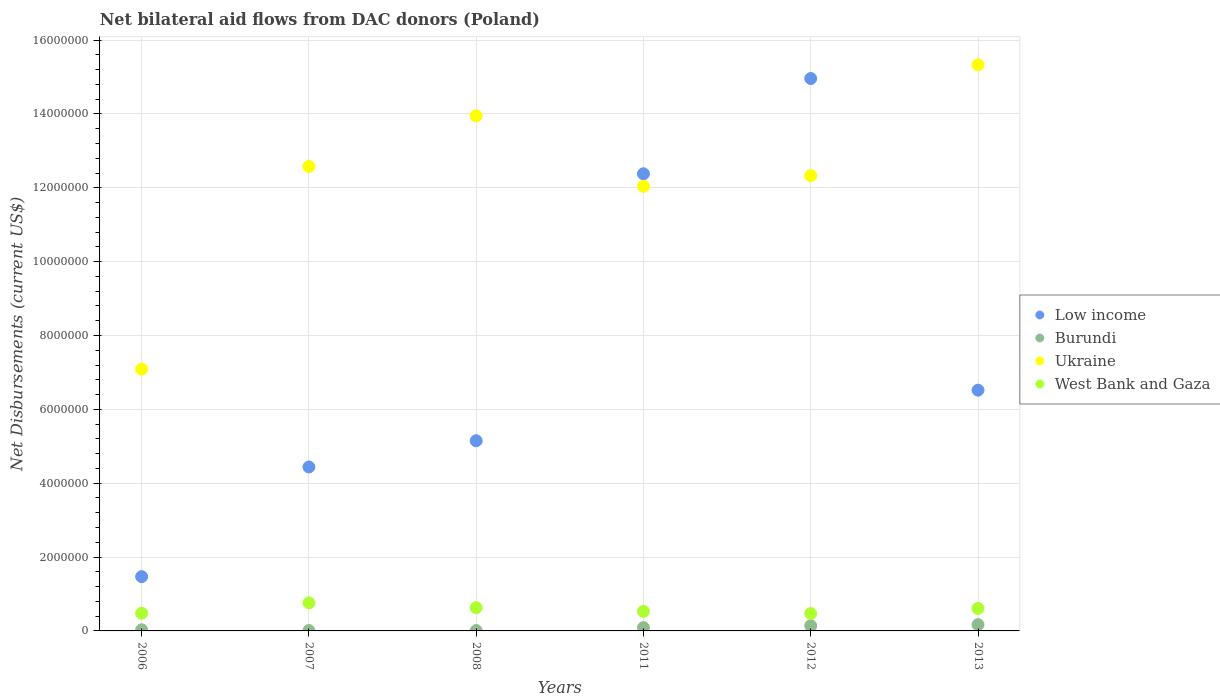How many different coloured dotlines are there?
Offer a terse response. 4. What is the net bilateral aid flows in Ukraine in 2008?
Provide a short and direct response. 1.40e+07. Across all years, what is the minimum net bilateral aid flows in Low income?
Keep it short and to the point. 1.47e+06. What is the total net bilateral aid flows in West Bank and Gaza in the graph?
Your response must be concise. 3.48e+06. What is the difference between the net bilateral aid flows in Burundi in 2006 and that in 2012?
Provide a succinct answer. -1.10e+05. What is the difference between the net bilateral aid flows in Low income in 2008 and the net bilateral aid flows in Ukraine in 2012?
Your response must be concise. -7.18e+06. What is the average net bilateral aid flows in Burundi per year?
Keep it short and to the point. 7.50e+04. In the year 2013, what is the difference between the net bilateral aid flows in Low income and net bilateral aid flows in Ukraine?
Give a very brief answer. -8.81e+06. In how many years, is the net bilateral aid flows in West Bank and Gaza greater than 12000000 US$?
Offer a terse response. 0. What is the ratio of the net bilateral aid flows in Ukraine in 2007 to that in 2011?
Ensure brevity in your answer.  1.04. Is the net bilateral aid flows in Ukraine in 2008 less than that in 2011?
Your response must be concise. No. Is the difference between the net bilateral aid flows in Low income in 2006 and 2007 greater than the difference between the net bilateral aid flows in Ukraine in 2006 and 2007?
Offer a very short reply. Yes. What is the difference between the highest and the second highest net bilateral aid flows in Burundi?
Keep it short and to the point. 3.00e+04. What is the difference between the highest and the lowest net bilateral aid flows in Ukraine?
Provide a short and direct response. 8.24e+06. In how many years, is the net bilateral aid flows in Ukraine greater than the average net bilateral aid flows in Ukraine taken over all years?
Offer a very short reply. 4. Is it the case that in every year, the sum of the net bilateral aid flows in West Bank and Gaza and net bilateral aid flows in Ukraine  is greater than the sum of net bilateral aid flows in Burundi and net bilateral aid flows in Low income?
Offer a very short reply. No. Is the net bilateral aid flows in Ukraine strictly greater than the net bilateral aid flows in Burundi over the years?
Your answer should be very brief. Yes. Is the net bilateral aid flows in Low income strictly less than the net bilateral aid flows in Ukraine over the years?
Your answer should be very brief. No. Does the graph contain any zero values?
Your response must be concise. No. Where does the legend appear in the graph?
Offer a terse response. Center right. How are the legend labels stacked?
Give a very brief answer. Vertical. What is the title of the graph?
Keep it short and to the point. Net bilateral aid flows from DAC donors (Poland). What is the label or title of the X-axis?
Keep it short and to the point. Years. What is the label or title of the Y-axis?
Your answer should be compact. Net Disbursements (current US$). What is the Net Disbursements (current US$) in Low income in 2006?
Make the answer very short. 1.47e+06. What is the Net Disbursements (current US$) of Burundi in 2006?
Make the answer very short. 3.00e+04. What is the Net Disbursements (current US$) of Ukraine in 2006?
Provide a short and direct response. 7.09e+06. What is the Net Disbursements (current US$) of West Bank and Gaza in 2006?
Your answer should be compact. 4.80e+05. What is the Net Disbursements (current US$) of Low income in 2007?
Offer a terse response. 4.44e+06. What is the Net Disbursements (current US$) in Burundi in 2007?
Ensure brevity in your answer.  10000. What is the Net Disbursements (current US$) of Ukraine in 2007?
Offer a very short reply. 1.26e+07. What is the Net Disbursements (current US$) in West Bank and Gaza in 2007?
Provide a succinct answer. 7.60e+05. What is the Net Disbursements (current US$) in Low income in 2008?
Offer a very short reply. 5.15e+06. What is the Net Disbursements (current US$) in Burundi in 2008?
Provide a short and direct response. 10000. What is the Net Disbursements (current US$) of Ukraine in 2008?
Make the answer very short. 1.40e+07. What is the Net Disbursements (current US$) of West Bank and Gaza in 2008?
Ensure brevity in your answer.  6.30e+05. What is the Net Disbursements (current US$) of Low income in 2011?
Your response must be concise. 1.24e+07. What is the Net Disbursements (current US$) of Burundi in 2011?
Give a very brief answer. 9.00e+04. What is the Net Disbursements (current US$) in Ukraine in 2011?
Your answer should be compact. 1.20e+07. What is the Net Disbursements (current US$) in West Bank and Gaza in 2011?
Make the answer very short. 5.30e+05. What is the Net Disbursements (current US$) in Low income in 2012?
Your response must be concise. 1.50e+07. What is the Net Disbursements (current US$) of Ukraine in 2012?
Ensure brevity in your answer.  1.23e+07. What is the Net Disbursements (current US$) of Low income in 2013?
Offer a very short reply. 6.52e+06. What is the Net Disbursements (current US$) of Ukraine in 2013?
Your answer should be compact. 1.53e+07. What is the Net Disbursements (current US$) in West Bank and Gaza in 2013?
Your answer should be compact. 6.10e+05. Across all years, what is the maximum Net Disbursements (current US$) in Low income?
Ensure brevity in your answer.  1.50e+07. Across all years, what is the maximum Net Disbursements (current US$) of Burundi?
Ensure brevity in your answer.  1.70e+05. Across all years, what is the maximum Net Disbursements (current US$) of Ukraine?
Keep it short and to the point. 1.53e+07. Across all years, what is the maximum Net Disbursements (current US$) of West Bank and Gaza?
Your answer should be very brief. 7.60e+05. Across all years, what is the minimum Net Disbursements (current US$) in Low income?
Your response must be concise. 1.47e+06. Across all years, what is the minimum Net Disbursements (current US$) of Burundi?
Offer a very short reply. 10000. Across all years, what is the minimum Net Disbursements (current US$) of Ukraine?
Offer a terse response. 7.09e+06. What is the total Net Disbursements (current US$) in Low income in the graph?
Your answer should be compact. 4.49e+07. What is the total Net Disbursements (current US$) in Ukraine in the graph?
Give a very brief answer. 7.33e+07. What is the total Net Disbursements (current US$) of West Bank and Gaza in the graph?
Make the answer very short. 3.48e+06. What is the difference between the Net Disbursements (current US$) in Low income in 2006 and that in 2007?
Give a very brief answer. -2.97e+06. What is the difference between the Net Disbursements (current US$) of Burundi in 2006 and that in 2007?
Keep it short and to the point. 2.00e+04. What is the difference between the Net Disbursements (current US$) in Ukraine in 2006 and that in 2007?
Offer a very short reply. -5.49e+06. What is the difference between the Net Disbursements (current US$) of West Bank and Gaza in 2006 and that in 2007?
Offer a terse response. -2.80e+05. What is the difference between the Net Disbursements (current US$) of Low income in 2006 and that in 2008?
Your response must be concise. -3.68e+06. What is the difference between the Net Disbursements (current US$) in Burundi in 2006 and that in 2008?
Provide a short and direct response. 2.00e+04. What is the difference between the Net Disbursements (current US$) in Ukraine in 2006 and that in 2008?
Your answer should be very brief. -6.86e+06. What is the difference between the Net Disbursements (current US$) in Low income in 2006 and that in 2011?
Give a very brief answer. -1.09e+07. What is the difference between the Net Disbursements (current US$) of Ukraine in 2006 and that in 2011?
Make the answer very short. -4.95e+06. What is the difference between the Net Disbursements (current US$) in Low income in 2006 and that in 2012?
Give a very brief answer. -1.35e+07. What is the difference between the Net Disbursements (current US$) of Ukraine in 2006 and that in 2012?
Keep it short and to the point. -5.24e+06. What is the difference between the Net Disbursements (current US$) in Low income in 2006 and that in 2013?
Your response must be concise. -5.05e+06. What is the difference between the Net Disbursements (current US$) in Burundi in 2006 and that in 2013?
Keep it short and to the point. -1.40e+05. What is the difference between the Net Disbursements (current US$) in Ukraine in 2006 and that in 2013?
Your answer should be very brief. -8.24e+06. What is the difference between the Net Disbursements (current US$) in West Bank and Gaza in 2006 and that in 2013?
Your response must be concise. -1.30e+05. What is the difference between the Net Disbursements (current US$) of Low income in 2007 and that in 2008?
Ensure brevity in your answer.  -7.10e+05. What is the difference between the Net Disbursements (current US$) in Ukraine in 2007 and that in 2008?
Your answer should be very brief. -1.37e+06. What is the difference between the Net Disbursements (current US$) in West Bank and Gaza in 2007 and that in 2008?
Keep it short and to the point. 1.30e+05. What is the difference between the Net Disbursements (current US$) in Low income in 2007 and that in 2011?
Offer a terse response. -7.94e+06. What is the difference between the Net Disbursements (current US$) in Ukraine in 2007 and that in 2011?
Give a very brief answer. 5.40e+05. What is the difference between the Net Disbursements (current US$) in West Bank and Gaza in 2007 and that in 2011?
Offer a very short reply. 2.30e+05. What is the difference between the Net Disbursements (current US$) of Low income in 2007 and that in 2012?
Your answer should be very brief. -1.05e+07. What is the difference between the Net Disbursements (current US$) of Ukraine in 2007 and that in 2012?
Give a very brief answer. 2.50e+05. What is the difference between the Net Disbursements (current US$) in West Bank and Gaza in 2007 and that in 2012?
Your answer should be very brief. 2.90e+05. What is the difference between the Net Disbursements (current US$) in Low income in 2007 and that in 2013?
Your response must be concise. -2.08e+06. What is the difference between the Net Disbursements (current US$) in Burundi in 2007 and that in 2013?
Keep it short and to the point. -1.60e+05. What is the difference between the Net Disbursements (current US$) of Ukraine in 2007 and that in 2013?
Your answer should be compact. -2.75e+06. What is the difference between the Net Disbursements (current US$) in Low income in 2008 and that in 2011?
Make the answer very short. -7.23e+06. What is the difference between the Net Disbursements (current US$) of Burundi in 2008 and that in 2011?
Make the answer very short. -8.00e+04. What is the difference between the Net Disbursements (current US$) in Ukraine in 2008 and that in 2011?
Make the answer very short. 1.91e+06. What is the difference between the Net Disbursements (current US$) in West Bank and Gaza in 2008 and that in 2011?
Make the answer very short. 1.00e+05. What is the difference between the Net Disbursements (current US$) in Low income in 2008 and that in 2012?
Ensure brevity in your answer.  -9.81e+06. What is the difference between the Net Disbursements (current US$) of Ukraine in 2008 and that in 2012?
Keep it short and to the point. 1.62e+06. What is the difference between the Net Disbursements (current US$) in West Bank and Gaza in 2008 and that in 2012?
Make the answer very short. 1.60e+05. What is the difference between the Net Disbursements (current US$) in Low income in 2008 and that in 2013?
Offer a terse response. -1.37e+06. What is the difference between the Net Disbursements (current US$) of Burundi in 2008 and that in 2013?
Keep it short and to the point. -1.60e+05. What is the difference between the Net Disbursements (current US$) in Ukraine in 2008 and that in 2013?
Ensure brevity in your answer.  -1.38e+06. What is the difference between the Net Disbursements (current US$) in West Bank and Gaza in 2008 and that in 2013?
Your answer should be very brief. 2.00e+04. What is the difference between the Net Disbursements (current US$) in Low income in 2011 and that in 2012?
Ensure brevity in your answer.  -2.58e+06. What is the difference between the Net Disbursements (current US$) in Burundi in 2011 and that in 2012?
Offer a very short reply. -5.00e+04. What is the difference between the Net Disbursements (current US$) in Ukraine in 2011 and that in 2012?
Provide a short and direct response. -2.90e+05. What is the difference between the Net Disbursements (current US$) of Low income in 2011 and that in 2013?
Offer a terse response. 5.86e+06. What is the difference between the Net Disbursements (current US$) in Burundi in 2011 and that in 2013?
Your answer should be very brief. -8.00e+04. What is the difference between the Net Disbursements (current US$) in Ukraine in 2011 and that in 2013?
Your response must be concise. -3.29e+06. What is the difference between the Net Disbursements (current US$) of Low income in 2012 and that in 2013?
Provide a short and direct response. 8.44e+06. What is the difference between the Net Disbursements (current US$) in Burundi in 2012 and that in 2013?
Give a very brief answer. -3.00e+04. What is the difference between the Net Disbursements (current US$) of West Bank and Gaza in 2012 and that in 2013?
Give a very brief answer. -1.40e+05. What is the difference between the Net Disbursements (current US$) in Low income in 2006 and the Net Disbursements (current US$) in Burundi in 2007?
Make the answer very short. 1.46e+06. What is the difference between the Net Disbursements (current US$) of Low income in 2006 and the Net Disbursements (current US$) of Ukraine in 2007?
Your response must be concise. -1.11e+07. What is the difference between the Net Disbursements (current US$) of Low income in 2006 and the Net Disbursements (current US$) of West Bank and Gaza in 2007?
Your answer should be compact. 7.10e+05. What is the difference between the Net Disbursements (current US$) in Burundi in 2006 and the Net Disbursements (current US$) in Ukraine in 2007?
Provide a succinct answer. -1.26e+07. What is the difference between the Net Disbursements (current US$) in Burundi in 2006 and the Net Disbursements (current US$) in West Bank and Gaza in 2007?
Your response must be concise. -7.30e+05. What is the difference between the Net Disbursements (current US$) of Ukraine in 2006 and the Net Disbursements (current US$) of West Bank and Gaza in 2007?
Provide a short and direct response. 6.33e+06. What is the difference between the Net Disbursements (current US$) of Low income in 2006 and the Net Disbursements (current US$) of Burundi in 2008?
Offer a terse response. 1.46e+06. What is the difference between the Net Disbursements (current US$) in Low income in 2006 and the Net Disbursements (current US$) in Ukraine in 2008?
Provide a succinct answer. -1.25e+07. What is the difference between the Net Disbursements (current US$) in Low income in 2006 and the Net Disbursements (current US$) in West Bank and Gaza in 2008?
Your answer should be compact. 8.40e+05. What is the difference between the Net Disbursements (current US$) of Burundi in 2006 and the Net Disbursements (current US$) of Ukraine in 2008?
Offer a terse response. -1.39e+07. What is the difference between the Net Disbursements (current US$) of Burundi in 2006 and the Net Disbursements (current US$) of West Bank and Gaza in 2008?
Keep it short and to the point. -6.00e+05. What is the difference between the Net Disbursements (current US$) of Ukraine in 2006 and the Net Disbursements (current US$) of West Bank and Gaza in 2008?
Ensure brevity in your answer.  6.46e+06. What is the difference between the Net Disbursements (current US$) in Low income in 2006 and the Net Disbursements (current US$) in Burundi in 2011?
Provide a succinct answer. 1.38e+06. What is the difference between the Net Disbursements (current US$) of Low income in 2006 and the Net Disbursements (current US$) of Ukraine in 2011?
Make the answer very short. -1.06e+07. What is the difference between the Net Disbursements (current US$) in Low income in 2006 and the Net Disbursements (current US$) in West Bank and Gaza in 2011?
Ensure brevity in your answer.  9.40e+05. What is the difference between the Net Disbursements (current US$) in Burundi in 2006 and the Net Disbursements (current US$) in Ukraine in 2011?
Your answer should be compact. -1.20e+07. What is the difference between the Net Disbursements (current US$) of Burundi in 2006 and the Net Disbursements (current US$) of West Bank and Gaza in 2011?
Your answer should be compact. -5.00e+05. What is the difference between the Net Disbursements (current US$) in Ukraine in 2006 and the Net Disbursements (current US$) in West Bank and Gaza in 2011?
Your answer should be compact. 6.56e+06. What is the difference between the Net Disbursements (current US$) in Low income in 2006 and the Net Disbursements (current US$) in Burundi in 2012?
Ensure brevity in your answer.  1.33e+06. What is the difference between the Net Disbursements (current US$) in Low income in 2006 and the Net Disbursements (current US$) in Ukraine in 2012?
Your answer should be compact. -1.09e+07. What is the difference between the Net Disbursements (current US$) of Low income in 2006 and the Net Disbursements (current US$) of West Bank and Gaza in 2012?
Offer a terse response. 1.00e+06. What is the difference between the Net Disbursements (current US$) in Burundi in 2006 and the Net Disbursements (current US$) in Ukraine in 2012?
Ensure brevity in your answer.  -1.23e+07. What is the difference between the Net Disbursements (current US$) of Burundi in 2006 and the Net Disbursements (current US$) of West Bank and Gaza in 2012?
Your answer should be very brief. -4.40e+05. What is the difference between the Net Disbursements (current US$) in Ukraine in 2006 and the Net Disbursements (current US$) in West Bank and Gaza in 2012?
Your answer should be very brief. 6.62e+06. What is the difference between the Net Disbursements (current US$) of Low income in 2006 and the Net Disbursements (current US$) of Burundi in 2013?
Give a very brief answer. 1.30e+06. What is the difference between the Net Disbursements (current US$) of Low income in 2006 and the Net Disbursements (current US$) of Ukraine in 2013?
Give a very brief answer. -1.39e+07. What is the difference between the Net Disbursements (current US$) in Low income in 2006 and the Net Disbursements (current US$) in West Bank and Gaza in 2013?
Your response must be concise. 8.60e+05. What is the difference between the Net Disbursements (current US$) in Burundi in 2006 and the Net Disbursements (current US$) in Ukraine in 2013?
Offer a very short reply. -1.53e+07. What is the difference between the Net Disbursements (current US$) in Burundi in 2006 and the Net Disbursements (current US$) in West Bank and Gaza in 2013?
Offer a terse response. -5.80e+05. What is the difference between the Net Disbursements (current US$) of Ukraine in 2006 and the Net Disbursements (current US$) of West Bank and Gaza in 2013?
Make the answer very short. 6.48e+06. What is the difference between the Net Disbursements (current US$) of Low income in 2007 and the Net Disbursements (current US$) of Burundi in 2008?
Offer a very short reply. 4.43e+06. What is the difference between the Net Disbursements (current US$) in Low income in 2007 and the Net Disbursements (current US$) in Ukraine in 2008?
Offer a terse response. -9.51e+06. What is the difference between the Net Disbursements (current US$) of Low income in 2007 and the Net Disbursements (current US$) of West Bank and Gaza in 2008?
Offer a very short reply. 3.81e+06. What is the difference between the Net Disbursements (current US$) in Burundi in 2007 and the Net Disbursements (current US$) in Ukraine in 2008?
Provide a short and direct response. -1.39e+07. What is the difference between the Net Disbursements (current US$) of Burundi in 2007 and the Net Disbursements (current US$) of West Bank and Gaza in 2008?
Your answer should be very brief. -6.20e+05. What is the difference between the Net Disbursements (current US$) in Ukraine in 2007 and the Net Disbursements (current US$) in West Bank and Gaza in 2008?
Your response must be concise. 1.20e+07. What is the difference between the Net Disbursements (current US$) of Low income in 2007 and the Net Disbursements (current US$) of Burundi in 2011?
Offer a very short reply. 4.35e+06. What is the difference between the Net Disbursements (current US$) of Low income in 2007 and the Net Disbursements (current US$) of Ukraine in 2011?
Provide a short and direct response. -7.60e+06. What is the difference between the Net Disbursements (current US$) in Low income in 2007 and the Net Disbursements (current US$) in West Bank and Gaza in 2011?
Your response must be concise. 3.91e+06. What is the difference between the Net Disbursements (current US$) of Burundi in 2007 and the Net Disbursements (current US$) of Ukraine in 2011?
Your response must be concise. -1.20e+07. What is the difference between the Net Disbursements (current US$) in Burundi in 2007 and the Net Disbursements (current US$) in West Bank and Gaza in 2011?
Your answer should be compact. -5.20e+05. What is the difference between the Net Disbursements (current US$) of Ukraine in 2007 and the Net Disbursements (current US$) of West Bank and Gaza in 2011?
Your response must be concise. 1.20e+07. What is the difference between the Net Disbursements (current US$) of Low income in 2007 and the Net Disbursements (current US$) of Burundi in 2012?
Offer a terse response. 4.30e+06. What is the difference between the Net Disbursements (current US$) of Low income in 2007 and the Net Disbursements (current US$) of Ukraine in 2012?
Make the answer very short. -7.89e+06. What is the difference between the Net Disbursements (current US$) in Low income in 2007 and the Net Disbursements (current US$) in West Bank and Gaza in 2012?
Your response must be concise. 3.97e+06. What is the difference between the Net Disbursements (current US$) in Burundi in 2007 and the Net Disbursements (current US$) in Ukraine in 2012?
Provide a succinct answer. -1.23e+07. What is the difference between the Net Disbursements (current US$) in Burundi in 2007 and the Net Disbursements (current US$) in West Bank and Gaza in 2012?
Provide a succinct answer. -4.60e+05. What is the difference between the Net Disbursements (current US$) in Ukraine in 2007 and the Net Disbursements (current US$) in West Bank and Gaza in 2012?
Provide a succinct answer. 1.21e+07. What is the difference between the Net Disbursements (current US$) of Low income in 2007 and the Net Disbursements (current US$) of Burundi in 2013?
Make the answer very short. 4.27e+06. What is the difference between the Net Disbursements (current US$) in Low income in 2007 and the Net Disbursements (current US$) in Ukraine in 2013?
Offer a very short reply. -1.09e+07. What is the difference between the Net Disbursements (current US$) in Low income in 2007 and the Net Disbursements (current US$) in West Bank and Gaza in 2013?
Keep it short and to the point. 3.83e+06. What is the difference between the Net Disbursements (current US$) in Burundi in 2007 and the Net Disbursements (current US$) in Ukraine in 2013?
Your answer should be very brief. -1.53e+07. What is the difference between the Net Disbursements (current US$) in Burundi in 2007 and the Net Disbursements (current US$) in West Bank and Gaza in 2013?
Offer a very short reply. -6.00e+05. What is the difference between the Net Disbursements (current US$) in Ukraine in 2007 and the Net Disbursements (current US$) in West Bank and Gaza in 2013?
Provide a short and direct response. 1.20e+07. What is the difference between the Net Disbursements (current US$) in Low income in 2008 and the Net Disbursements (current US$) in Burundi in 2011?
Give a very brief answer. 5.06e+06. What is the difference between the Net Disbursements (current US$) in Low income in 2008 and the Net Disbursements (current US$) in Ukraine in 2011?
Keep it short and to the point. -6.89e+06. What is the difference between the Net Disbursements (current US$) of Low income in 2008 and the Net Disbursements (current US$) of West Bank and Gaza in 2011?
Your answer should be very brief. 4.62e+06. What is the difference between the Net Disbursements (current US$) of Burundi in 2008 and the Net Disbursements (current US$) of Ukraine in 2011?
Provide a succinct answer. -1.20e+07. What is the difference between the Net Disbursements (current US$) in Burundi in 2008 and the Net Disbursements (current US$) in West Bank and Gaza in 2011?
Your answer should be compact. -5.20e+05. What is the difference between the Net Disbursements (current US$) in Ukraine in 2008 and the Net Disbursements (current US$) in West Bank and Gaza in 2011?
Keep it short and to the point. 1.34e+07. What is the difference between the Net Disbursements (current US$) of Low income in 2008 and the Net Disbursements (current US$) of Burundi in 2012?
Your answer should be very brief. 5.01e+06. What is the difference between the Net Disbursements (current US$) of Low income in 2008 and the Net Disbursements (current US$) of Ukraine in 2012?
Your answer should be compact. -7.18e+06. What is the difference between the Net Disbursements (current US$) of Low income in 2008 and the Net Disbursements (current US$) of West Bank and Gaza in 2012?
Provide a succinct answer. 4.68e+06. What is the difference between the Net Disbursements (current US$) of Burundi in 2008 and the Net Disbursements (current US$) of Ukraine in 2012?
Offer a very short reply. -1.23e+07. What is the difference between the Net Disbursements (current US$) in Burundi in 2008 and the Net Disbursements (current US$) in West Bank and Gaza in 2012?
Keep it short and to the point. -4.60e+05. What is the difference between the Net Disbursements (current US$) in Ukraine in 2008 and the Net Disbursements (current US$) in West Bank and Gaza in 2012?
Provide a succinct answer. 1.35e+07. What is the difference between the Net Disbursements (current US$) of Low income in 2008 and the Net Disbursements (current US$) of Burundi in 2013?
Your response must be concise. 4.98e+06. What is the difference between the Net Disbursements (current US$) of Low income in 2008 and the Net Disbursements (current US$) of Ukraine in 2013?
Keep it short and to the point. -1.02e+07. What is the difference between the Net Disbursements (current US$) in Low income in 2008 and the Net Disbursements (current US$) in West Bank and Gaza in 2013?
Keep it short and to the point. 4.54e+06. What is the difference between the Net Disbursements (current US$) of Burundi in 2008 and the Net Disbursements (current US$) of Ukraine in 2013?
Keep it short and to the point. -1.53e+07. What is the difference between the Net Disbursements (current US$) in Burundi in 2008 and the Net Disbursements (current US$) in West Bank and Gaza in 2013?
Your answer should be very brief. -6.00e+05. What is the difference between the Net Disbursements (current US$) of Ukraine in 2008 and the Net Disbursements (current US$) of West Bank and Gaza in 2013?
Your answer should be compact. 1.33e+07. What is the difference between the Net Disbursements (current US$) of Low income in 2011 and the Net Disbursements (current US$) of Burundi in 2012?
Offer a very short reply. 1.22e+07. What is the difference between the Net Disbursements (current US$) of Low income in 2011 and the Net Disbursements (current US$) of West Bank and Gaza in 2012?
Give a very brief answer. 1.19e+07. What is the difference between the Net Disbursements (current US$) in Burundi in 2011 and the Net Disbursements (current US$) in Ukraine in 2012?
Provide a short and direct response. -1.22e+07. What is the difference between the Net Disbursements (current US$) in Burundi in 2011 and the Net Disbursements (current US$) in West Bank and Gaza in 2012?
Offer a very short reply. -3.80e+05. What is the difference between the Net Disbursements (current US$) of Ukraine in 2011 and the Net Disbursements (current US$) of West Bank and Gaza in 2012?
Provide a short and direct response. 1.16e+07. What is the difference between the Net Disbursements (current US$) of Low income in 2011 and the Net Disbursements (current US$) of Burundi in 2013?
Provide a succinct answer. 1.22e+07. What is the difference between the Net Disbursements (current US$) of Low income in 2011 and the Net Disbursements (current US$) of Ukraine in 2013?
Offer a very short reply. -2.95e+06. What is the difference between the Net Disbursements (current US$) of Low income in 2011 and the Net Disbursements (current US$) of West Bank and Gaza in 2013?
Provide a succinct answer. 1.18e+07. What is the difference between the Net Disbursements (current US$) of Burundi in 2011 and the Net Disbursements (current US$) of Ukraine in 2013?
Keep it short and to the point. -1.52e+07. What is the difference between the Net Disbursements (current US$) of Burundi in 2011 and the Net Disbursements (current US$) of West Bank and Gaza in 2013?
Your answer should be very brief. -5.20e+05. What is the difference between the Net Disbursements (current US$) in Ukraine in 2011 and the Net Disbursements (current US$) in West Bank and Gaza in 2013?
Provide a short and direct response. 1.14e+07. What is the difference between the Net Disbursements (current US$) of Low income in 2012 and the Net Disbursements (current US$) of Burundi in 2013?
Your answer should be very brief. 1.48e+07. What is the difference between the Net Disbursements (current US$) in Low income in 2012 and the Net Disbursements (current US$) in Ukraine in 2013?
Your answer should be compact. -3.70e+05. What is the difference between the Net Disbursements (current US$) in Low income in 2012 and the Net Disbursements (current US$) in West Bank and Gaza in 2013?
Offer a terse response. 1.44e+07. What is the difference between the Net Disbursements (current US$) of Burundi in 2012 and the Net Disbursements (current US$) of Ukraine in 2013?
Keep it short and to the point. -1.52e+07. What is the difference between the Net Disbursements (current US$) in Burundi in 2012 and the Net Disbursements (current US$) in West Bank and Gaza in 2013?
Your answer should be compact. -4.70e+05. What is the difference between the Net Disbursements (current US$) of Ukraine in 2012 and the Net Disbursements (current US$) of West Bank and Gaza in 2013?
Provide a short and direct response. 1.17e+07. What is the average Net Disbursements (current US$) of Low income per year?
Your answer should be compact. 7.49e+06. What is the average Net Disbursements (current US$) of Burundi per year?
Keep it short and to the point. 7.50e+04. What is the average Net Disbursements (current US$) of Ukraine per year?
Make the answer very short. 1.22e+07. What is the average Net Disbursements (current US$) of West Bank and Gaza per year?
Ensure brevity in your answer.  5.80e+05. In the year 2006, what is the difference between the Net Disbursements (current US$) of Low income and Net Disbursements (current US$) of Burundi?
Your answer should be very brief. 1.44e+06. In the year 2006, what is the difference between the Net Disbursements (current US$) in Low income and Net Disbursements (current US$) in Ukraine?
Provide a short and direct response. -5.62e+06. In the year 2006, what is the difference between the Net Disbursements (current US$) in Low income and Net Disbursements (current US$) in West Bank and Gaza?
Offer a terse response. 9.90e+05. In the year 2006, what is the difference between the Net Disbursements (current US$) of Burundi and Net Disbursements (current US$) of Ukraine?
Your response must be concise. -7.06e+06. In the year 2006, what is the difference between the Net Disbursements (current US$) in Burundi and Net Disbursements (current US$) in West Bank and Gaza?
Your answer should be very brief. -4.50e+05. In the year 2006, what is the difference between the Net Disbursements (current US$) of Ukraine and Net Disbursements (current US$) of West Bank and Gaza?
Make the answer very short. 6.61e+06. In the year 2007, what is the difference between the Net Disbursements (current US$) in Low income and Net Disbursements (current US$) in Burundi?
Ensure brevity in your answer.  4.43e+06. In the year 2007, what is the difference between the Net Disbursements (current US$) of Low income and Net Disbursements (current US$) of Ukraine?
Offer a terse response. -8.14e+06. In the year 2007, what is the difference between the Net Disbursements (current US$) in Low income and Net Disbursements (current US$) in West Bank and Gaza?
Your answer should be very brief. 3.68e+06. In the year 2007, what is the difference between the Net Disbursements (current US$) of Burundi and Net Disbursements (current US$) of Ukraine?
Keep it short and to the point. -1.26e+07. In the year 2007, what is the difference between the Net Disbursements (current US$) of Burundi and Net Disbursements (current US$) of West Bank and Gaza?
Your answer should be very brief. -7.50e+05. In the year 2007, what is the difference between the Net Disbursements (current US$) in Ukraine and Net Disbursements (current US$) in West Bank and Gaza?
Ensure brevity in your answer.  1.18e+07. In the year 2008, what is the difference between the Net Disbursements (current US$) of Low income and Net Disbursements (current US$) of Burundi?
Give a very brief answer. 5.14e+06. In the year 2008, what is the difference between the Net Disbursements (current US$) in Low income and Net Disbursements (current US$) in Ukraine?
Ensure brevity in your answer.  -8.80e+06. In the year 2008, what is the difference between the Net Disbursements (current US$) of Low income and Net Disbursements (current US$) of West Bank and Gaza?
Your answer should be compact. 4.52e+06. In the year 2008, what is the difference between the Net Disbursements (current US$) of Burundi and Net Disbursements (current US$) of Ukraine?
Keep it short and to the point. -1.39e+07. In the year 2008, what is the difference between the Net Disbursements (current US$) in Burundi and Net Disbursements (current US$) in West Bank and Gaza?
Your answer should be compact. -6.20e+05. In the year 2008, what is the difference between the Net Disbursements (current US$) in Ukraine and Net Disbursements (current US$) in West Bank and Gaza?
Keep it short and to the point. 1.33e+07. In the year 2011, what is the difference between the Net Disbursements (current US$) of Low income and Net Disbursements (current US$) of Burundi?
Your answer should be very brief. 1.23e+07. In the year 2011, what is the difference between the Net Disbursements (current US$) in Low income and Net Disbursements (current US$) in West Bank and Gaza?
Offer a very short reply. 1.18e+07. In the year 2011, what is the difference between the Net Disbursements (current US$) of Burundi and Net Disbursements (current US$) of Ukraine?
Your answer should be very brief. -1.20e+07. In the year 2011, what is the difference between the Net Disbursements (current US$) in Burundi and Net Disbursements (current US$) in West Bank and Gaza?
Offer a very short reply. -4.40e+05. In the year 2011, what is the difference between the Net Disbursements (current US$) in Ukraine and Net Disbursements (current US$) in West Bank and Gaza?
Make the answer very short. 1.15e+07. In the year 2012, what is the difference between the Net Disbursements (current US$) of Low income and Net Disbursements (current US$) of Burundi?
Keep it short and to the point. 1.48e+07. In the year 2012, what is the difference between the Net Disbursements (current US$) of Low income and Net Disbursements (current US$) of Ukraine?
Provide a short and direct response. 2.63e+06. In the year 2012, what is the difference between the Net Disbursements (current US$) of Low income and Net Disbursements (current US$) of West Bank and Gaza?
Your answer should be compact. 1.45e+07. In the year 2012, what is the difference between the Net Disbursements (current US$) of Burundi and Net Disbursements (current US$) of Ukraine?
Provide a succinct answer. -1.22e+07. In the year 2012, what is the difference between the Net Disbursements (current US$) of Burundi and Net Disbursements (current US$) of West Bank and Gaza?
Provide a short and direct response. -3.30e+05. In the year 2012, what is the difference between the Net Disbursements (current US$) in Ukraine and Net Disbursements (current US$) in West Bank and Gaza?
Ensure brevity in your answer.  1.19e+07. In the year 2013, what is the difference between the Net Disbursements (current US$) of Low income and Net Disbursements (current US$) of Burundi?
Give a very brief answer. 6.35e+06. In the year 2013, what is the difference between the Net Disbursements (current US$) of Low income and Net Disbursements (current US$) of Ukraine?
Offer a terse response. -8.81e+06. In the year 2013, what is the difference between the Net Disbursements (current US$) in Low income and Net Disbursements (current US$) in West Bank and Gaza?
Offer a terse response. 5.91e+06. In the year 2013, what is the difference between the Net Disbursements (current US$) in Burundi and Net Disbursements (current US$) in Ukraine?
Your answer should be very brief. -1.52e+07. In the year 2013, what is the difference between the Net Disbursements (current US$) of Burundi and Net Disbursements (current US$) of West Bank and Gaza?
Give a very brief answer. -4.40e+05. In the year 2013, what is the difference between the Net Disbursements (current US$) in Ukraine and Net Disbursements (current US$) in West Bank and Gaza?
Provide a succinct answer. 1.47e+07. What is the ratio of the Net Disbursements (current US$) of Low income in 2006 to that in 2007?
Your response must be concise. 0.33. What is the ratio of the Net Disbursements (current US$) in Ukraine in 2006 to that in 2007?
Provide a short and direct response. 0.56. What is the ratio of the Net Disbursements (current US$) in West Bank and Gaza in 2006 to that in 2007?
Your response must be concise. 0.63. What is the ratio of the Net Disbursements (current US$) of Low income in 2006 to that in 2008?
Offer a terse response. 0.29. What is the ratio of the Net Disbursements (current US$) of Ukraine in 2006 to that in 2008?
Your answer should be very brief. 0.51. What is the ratio of the Net Disbursements (current US$) in West Bank and Gaza in 2006 to that in 2008?
Give a very brief answer. 0.76. What is the ratio of the Net Disbursements (current US$) of Low income in 2006 to that in 2011?
Offer a very short reply. 0.12. What is the ratio of the Net Disbursements (current US$) of Ukraine in 2006 to that in 2011?
Your answer should be compact. 0.59. What is the ratio of the Net Disbursements (current US$) of West Bank and Gaza in 2006 to that in 2011?
Give a very brief answer. 0.91. What is the ratio of the Net Disbursements (current US$) in Low income in 2006 to that in 2012?
Offer a terse response. 0.1. What is the ratio of the Net Disbursements (current US$) in Burundi in 2006 to that in 2012?
Your answer should be very brief. 0.21. What is the ratio of the Net Disbursements (current US$) in Ukraine in 2006 to that in 2012?
Offer a very short reply. 0.57. What is the ratio of the Net Disbursements (current US$) in West Bank and Gaza in 2006 to that in 2012?
Your response must be concise. 1.02. What is the ratio of the Net Disbursements (current US$) of Low income in 2006 to that in 2013?
Your answer should be compact. 0.23. What is the ratio of the Net Disbursements (current US$) of Burundi in 2006 to that in 2013?
Give a very brief answer. 0.18. What is the ratio of the Net Disbursements (current US$) in Ukraine in 2006 to that in 2013?
Provide a succinct answer. 0.46. What is the ratio of the Net Disbursements (current US$) of West Bank and Gaza in 2006 to that in 2013?
Make the answer very short. 0.79. What is the ratio of the Net Disbursements (current US$) of Low income in 2007 to that in 2008?
Keep it short and to the point. 0.86. What is the ratio of the Net Disbursements (current US$) of Ukraine in 2007 to that in 2008?
Provide a succinct answer. 0.9. What is the ratio of the Net Disbursements (current US$) of West Bank and Gaza in 2007 to that in 2008?
Give a very brief answer. 1.21. What is the ratio of the Net Disbursements (current US$) in Low income in 2007 to that in 2011?
Provide a succinct answer. 0.36. What is the ratio of the Net Disbursements (current US$) in Burundi in 2007 to that in 2011?
Give a very brief answer. 0.11. What is the ratio of the Net Disbursements (current US$) of Ukraine in 2007 to that in 2011?
Provide a short and direct response. 1.04. What is the ratio of the Net Disbursements (current US$) in West Bank and Gaza in 2007 to that in 2011?
Give a very brief answer. 1.43. What is the ratio of the Net Disbursements (current US$) in Low income in 2007 to that in 2012?
Ensure brevity in your answer.  0.3. What is the ratio of the Net Disbursements (current US$) of Burundi in 2007 to that in 2012?
Ensure brevity in your answer.  0.07. What is the ratio of the Net Disbursements (current US$) of Ukraine in 2007 to that in 2012?
Your answer should be compact. 1.02. What is the ratio of the Net Disbursements (current US$) of West Bank and Gaza in 2007 to that in 2012?
Keep it short and to the point. 1.62. What is the ratio of the Net Disbursements (current US$) of Low income in 2007 to that in 2013?
Provide a succinct answer. 0.68. What is the ratio of the Net Disbursements (current US$) in Burundi in 2007 to that in 2013?
Your answer should be compact. 0.06. What is the ratio of the Net Disbursements (current US$) in Ukraine in 2007 to that in 2013?
Provide a short and direct response. 0.82. What is the ratio of the Net Disbursements (current US$) in West Bank and Gaza in 2007 to that in 2013?
Offer a terse response. 1.25. What is the ratio of the Net Disbursements (current US$) in Low income in 2008 to that in 2011?
Your response must be concise. 0.42. What is the ratio of the Net Disbursements (current US$) in Ukraine in 2008 to that in 2011?
Offer a terse response. 1.16. What is the ratio of the Net Disbursements (current US$) in West Bank and Gaza in 2008 to that in 2011?
Provide a short and direct response. 1.19. What is the ratio of the Net Disbursements (current US$) of Low income in 2008 to that in 2012?
Offer a terse response. 0.34. What is the ratio of the Net Disbursements (current US$) of Burundi in 2008 to that in 2012?
Your response must be concise. 0.07. What is the ratio of the Net Disbursements (current US$) of Ukraine in 2008 to that in 2012?
Your answer should be very brief. 1.13. What is the ratio of the Net Disbursements (current US$) of West Bank and Gaza in 2008 to that in 2012?
Offer a terse response. 1.34. What is the ratio of the Net Disbursements (current US$) in Low income in 2008 to that in 2013?
Ensure brevity in your answer.  0.79. What is the ratio of the Net Disbursements (current US$) in Burundi in 2008 to that in 2013?
Give a very brief answer. 0.06. What is the ratio of the Net Disbursements (current US$) of Ukraine in 2008 to that in 2013?
Ensure brevity in your answer.  0.91. What is the ratio of the Net Disbursements (current US$) of West Bank and Gaza in 2008 to that in 2013?
Provide a succinct answer. 1.03. What is the ratio of the Net Disbursements (current US$) in Low income in 2011 to that in 2012?
Provide a succinct answer. 0.83. What is the ratio of the Net Disbursements (current US$) in Burundi in 2011 to that in 2012?
Your answer should be compact. 0.64. What is the ratio of the Net Disbursements (current US$) in Ukraine in 2011 to that in 2012?
Ensure brevity in your answer.  0.98. What is the ratio of the Net Disbursements (current US$) in West Bank and Gaza in 2011 to that in 2012?
Offer a terse response. 1.13. What is the ratio of the Net Disbursements (current US$) of Low income in 2011 to that in 2013?
Make the answer very short. 1.9. What is the ratio of the Net Disbursements (current US$) of Burundi in 2011 to that in 2013?
Make the answer very short. 0.53. What is the ratio of the Net Disbursements (current US$) in Ukraine in 2011 to that in 2013?
Ensure brevity in your answer.  0.79. What is the ratio of the Net Disbursements (current US$) of West Bank and Gaza in 2011 to that in 2013?
Offer a terse response. 0.87. What is the ratio of the Net Disbursements (current US$) of Low income in 2012 to that in 2013?
Your response must be concise. 2.29. What is the ratio of the Net Disbursements (current US$) of Burundi in 2012 to that in 2013?
Provide a succinct answer. 0.82. What is the ratio of the Net Disbursements (current US$) in Ukraine in 2012 to that in 2013?
Give a very brief answer. 0.8. What is the ratio of the Net Disbursements (current US$) of West Bank and Gaza in 2012 to that in 2013?
Offer a terse response. 0.77. What is the difference between the highest and the second highest Net Disbursements (current US$) of Low income?
Your response must be concise. 2.58e+06. What is the difference between the highest and the second highest Net Disbursements (current US$) in Burundi?
Offer a terse response. 3.00e+04. What is the difference between the highest and the second highest Net Disbursements (current US$) in Ukraine?
Your answer should be very brief. 1.38e+06. What is the difference between the highest and the lowest Net Disbursements (current US$) in Low income?
Keep it short and to the point. 1.35e+07. What is the difference between the highest and the lowest Net Disbursements (current US$) in Burundi?
Provide a short and direct response. 1.60e+05. What is the difference between the highest and the lowest Net Disbursements (current US$) of Ukraine?
Make the answer very short. 8.24e+06. What is the difference between the highest and the lowest Net Disbursements (current US$) of West Bank and Gaza?
Provide a succinct answer. 2.90e+05. 